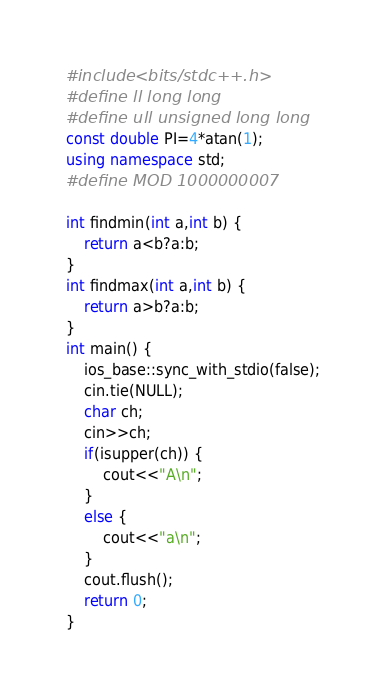<code> <loc_0><loc_0><loc_500><loc_500><_C++_>#include <bits/stdc++.h>
#define ll long long
#define ull unsigned long long
const double PI=4*atan(1);
using namespace std;
#define MOD 1000000007

int findmin(int a,int b) {
    return a<b?a:b;
}
int findmax(int a,int b) {
    return a>b?a:b;
}
int main() {
    ios_base::sync_with_stdio(false);
    cin.tie(NULL);
    char ch;
    cin>>ch;
    if(isupper(ch)) {
		cout<<"A\n";
	}
	else {
		cout<<"a\n";
	}
    cout.flush();
    return 0;
}
</code> 